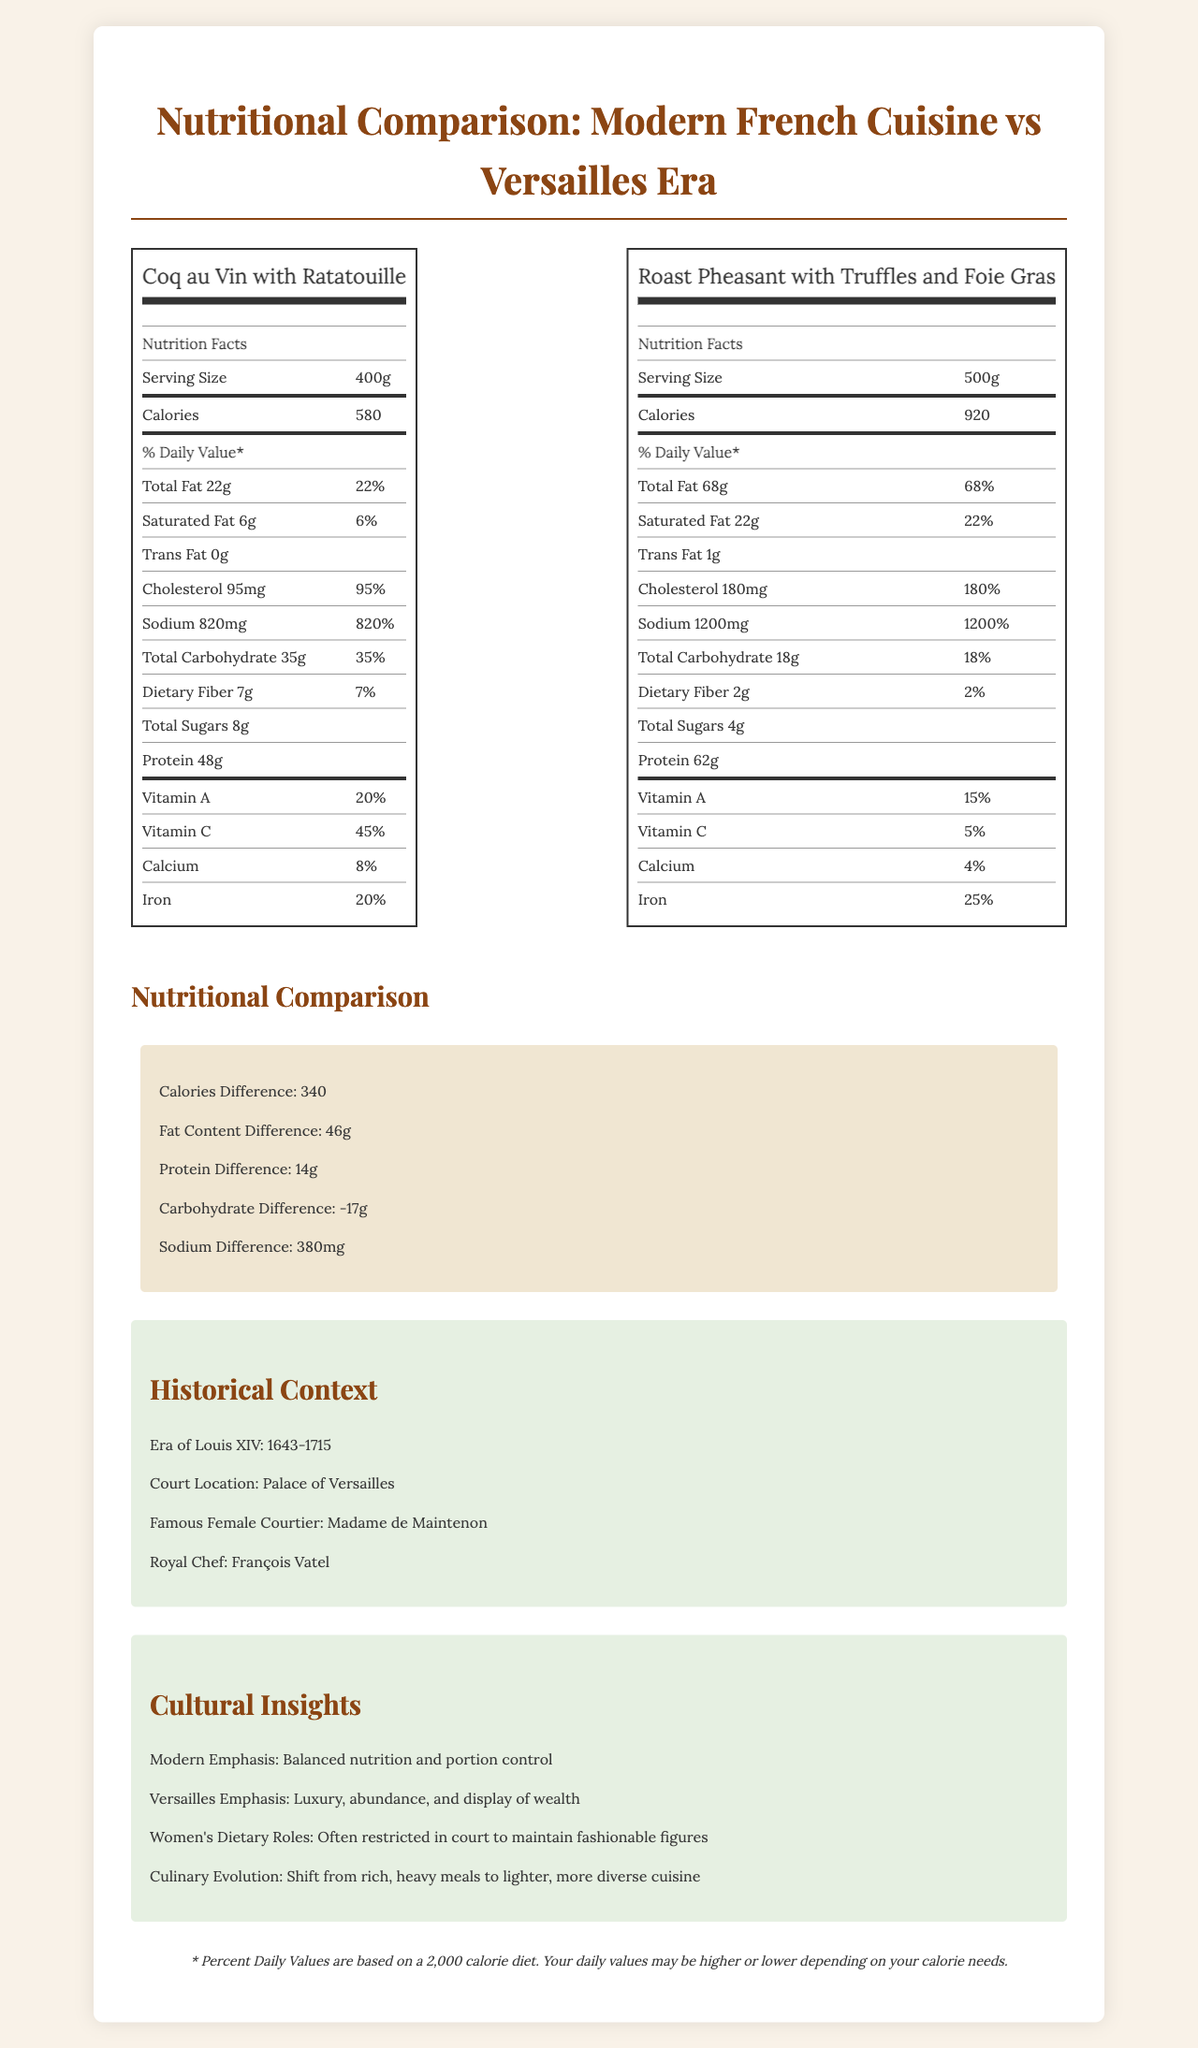who was the famous female courtier during Louis XIV's reign? The document mentions that the famous female courtier at the court of Louis XIV was Madame de Maintenon.
Answer: Madame de Maintenon what is the calorie difference between the modern French meal and the Versailles meal? The document lists the calorie difference under "Nutritional Comparison" as 340.
Answer: 340 How much saturated fat does the modern French meal contain? The modern French meal contains 6g of saturated fat, as stated in its nutritional label.
Answer: 6g What is the serving size for the Versailles meal? The serving size of the Versailles meal, "Roast Pheasant with Truffles and Foie Gras," is 500g.
Answer: 500g How many grams of protein are in the modern French meal? The nutritional label for "Coq au Vin with Ratatouille" lists 48g of protein.
Answer: 48g Which meal has more sodium? A. Modern French Meal B. Versailles Meal The Versailles meal has 1200mg of sodium, which is higher than the 820mg in the modern French meal.
Answer: B What is one key difference in the cultural emphasis of the meals? A. Focus on culinary simplicity B. Emphasis on portion control C. Display of wealth and luxury The Versailles meal's cultural emphasis is on "Luxury, abundance, and display of wealth," whereas modern meals focus on "Balanced nutrition and portion control."
Answer: C True or False: The modern French meal has more iron than the Versailles meal? The modern French meal has 20% iron, whereas the Versailles meal has 25% iron.
Answer: False Summarize the main idea of the document. The document compares the nutritional content and cultural context of the "Coq au Vin with Ratatouille" and "Roast Pheasant with Truffles and Foie Gras," illustrating dietary practices from the time of Louis XIV to today. It underlines how meals have shifted from rich, luxurious foods to more balanced nutrition.
Answer: The document provides a nutritional comparison between a modern French meal and a typical meal from the Versailles era, highlighting differences in calories, fat, protein, carbohydrates, and sodium. It also offers historical context on the court of Louis XIV and cultural insights on the evolution of French cuisine. What was the daily life of Madame de Maintenon like at Versailles? The document does not provide details about the daily life of Madame de Maintenon at Versailles. It only mentions her as a famous female courtier.
Answer: Not enough information 